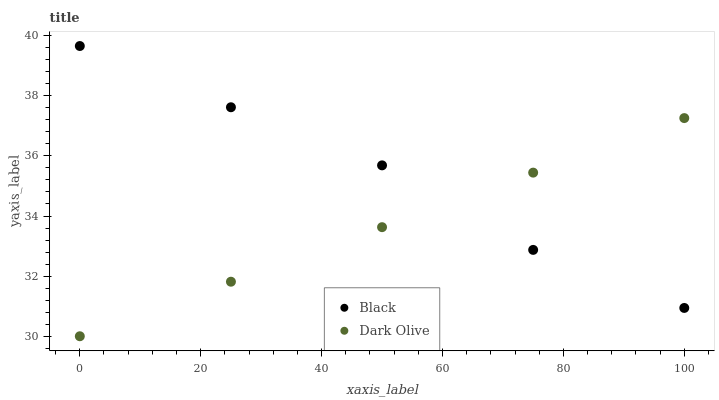Does Dark Olive have the minimum area under the curve?
Answer yes or no. Yes. Does Black have the maximum area under the curve?
Answer yes or no. Yes. Does Black have the minimum area under the curve?
Answer yes or no. No. Is Dark Olive the smoothest?
Answer yes or no. Yes. Is Black the roughest?
Answer yes or no. Yes. Is Black the smoothest?
Answer yes or no. No. Does Dark Olive have the lowest value?
Answer yes or no. Yes. Does Black have the lowest value?
Answer yes or no. No. Does Black have the highest value?
Answer yes or no. Yes. Does Black intersect Dark Olive?
Answer yes or no. Yes. Is Black less than Dark Olive?
Answer yes or no. No. Is Black greater than Dark Olive?
Answer yes or no. No. 